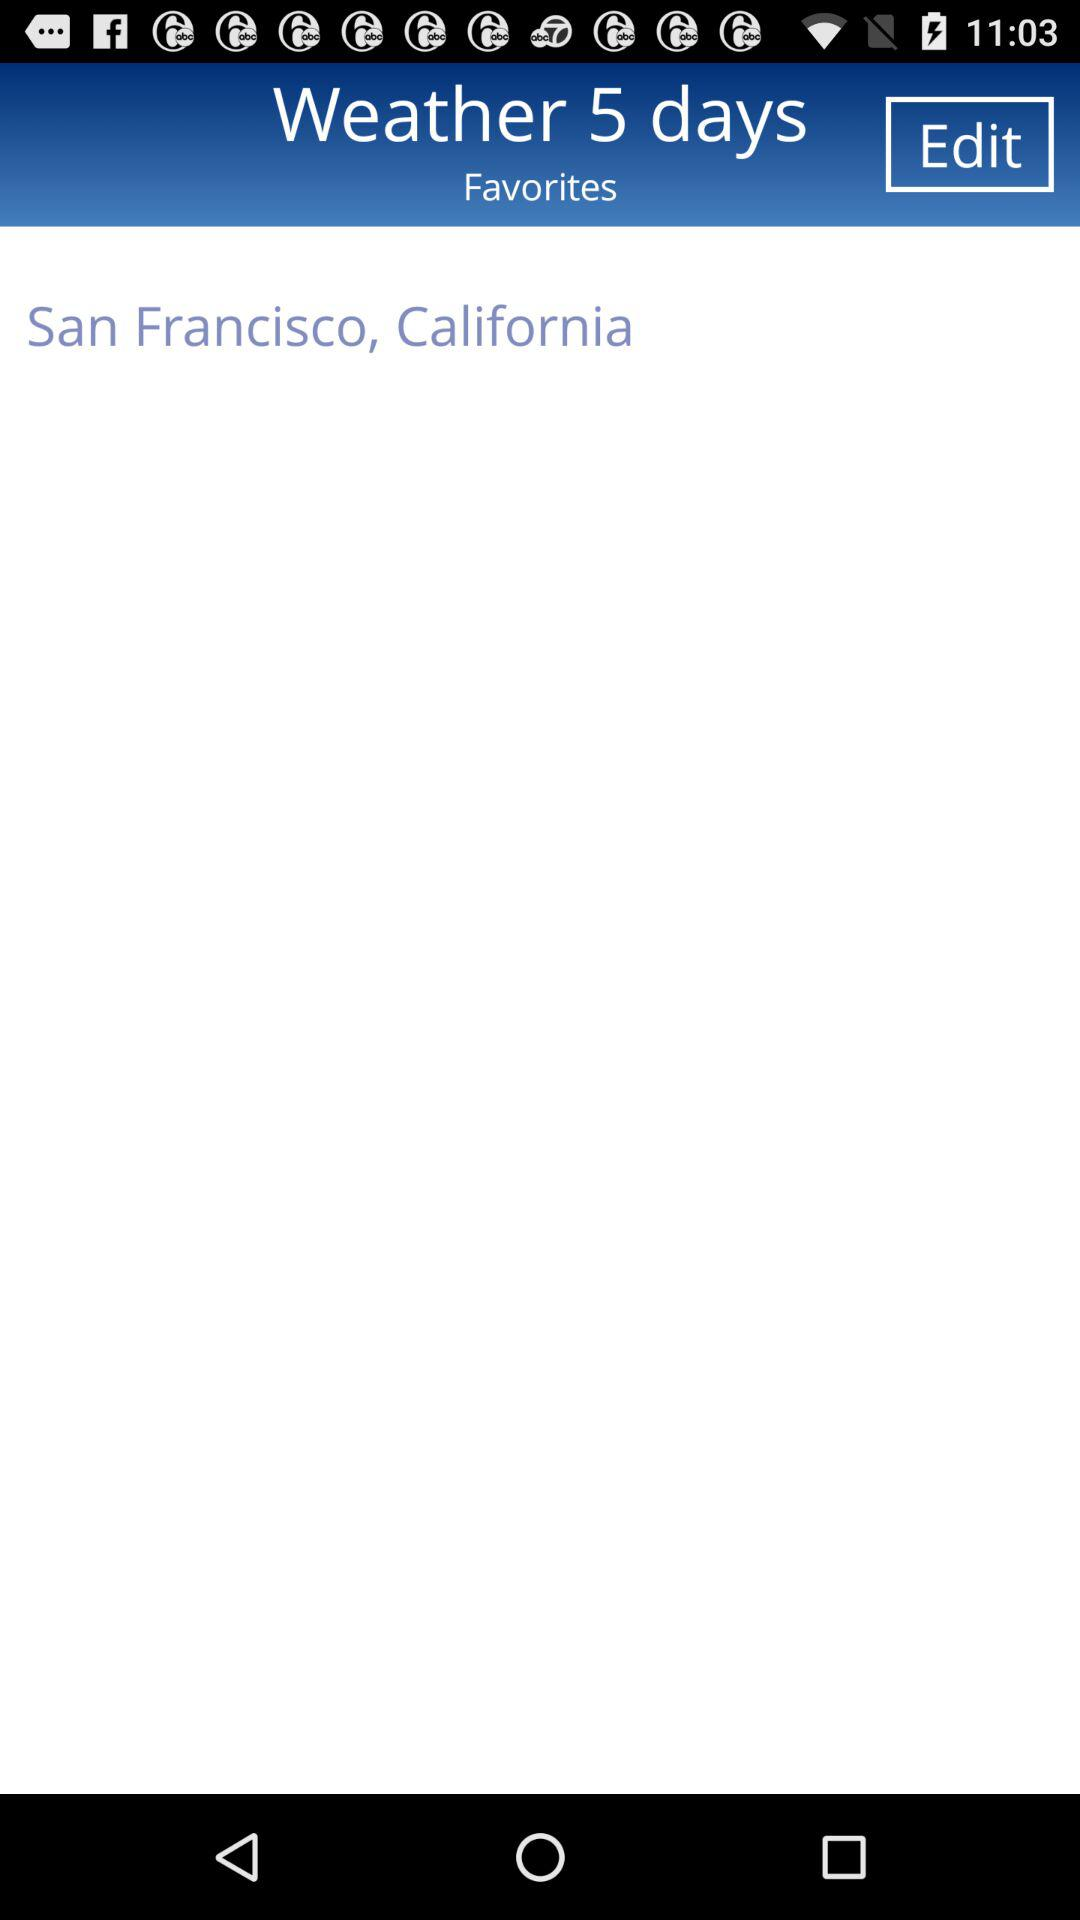Weather shows of how many days?
When the provided information is insufficient, respond with <no answer>. <no answer> 